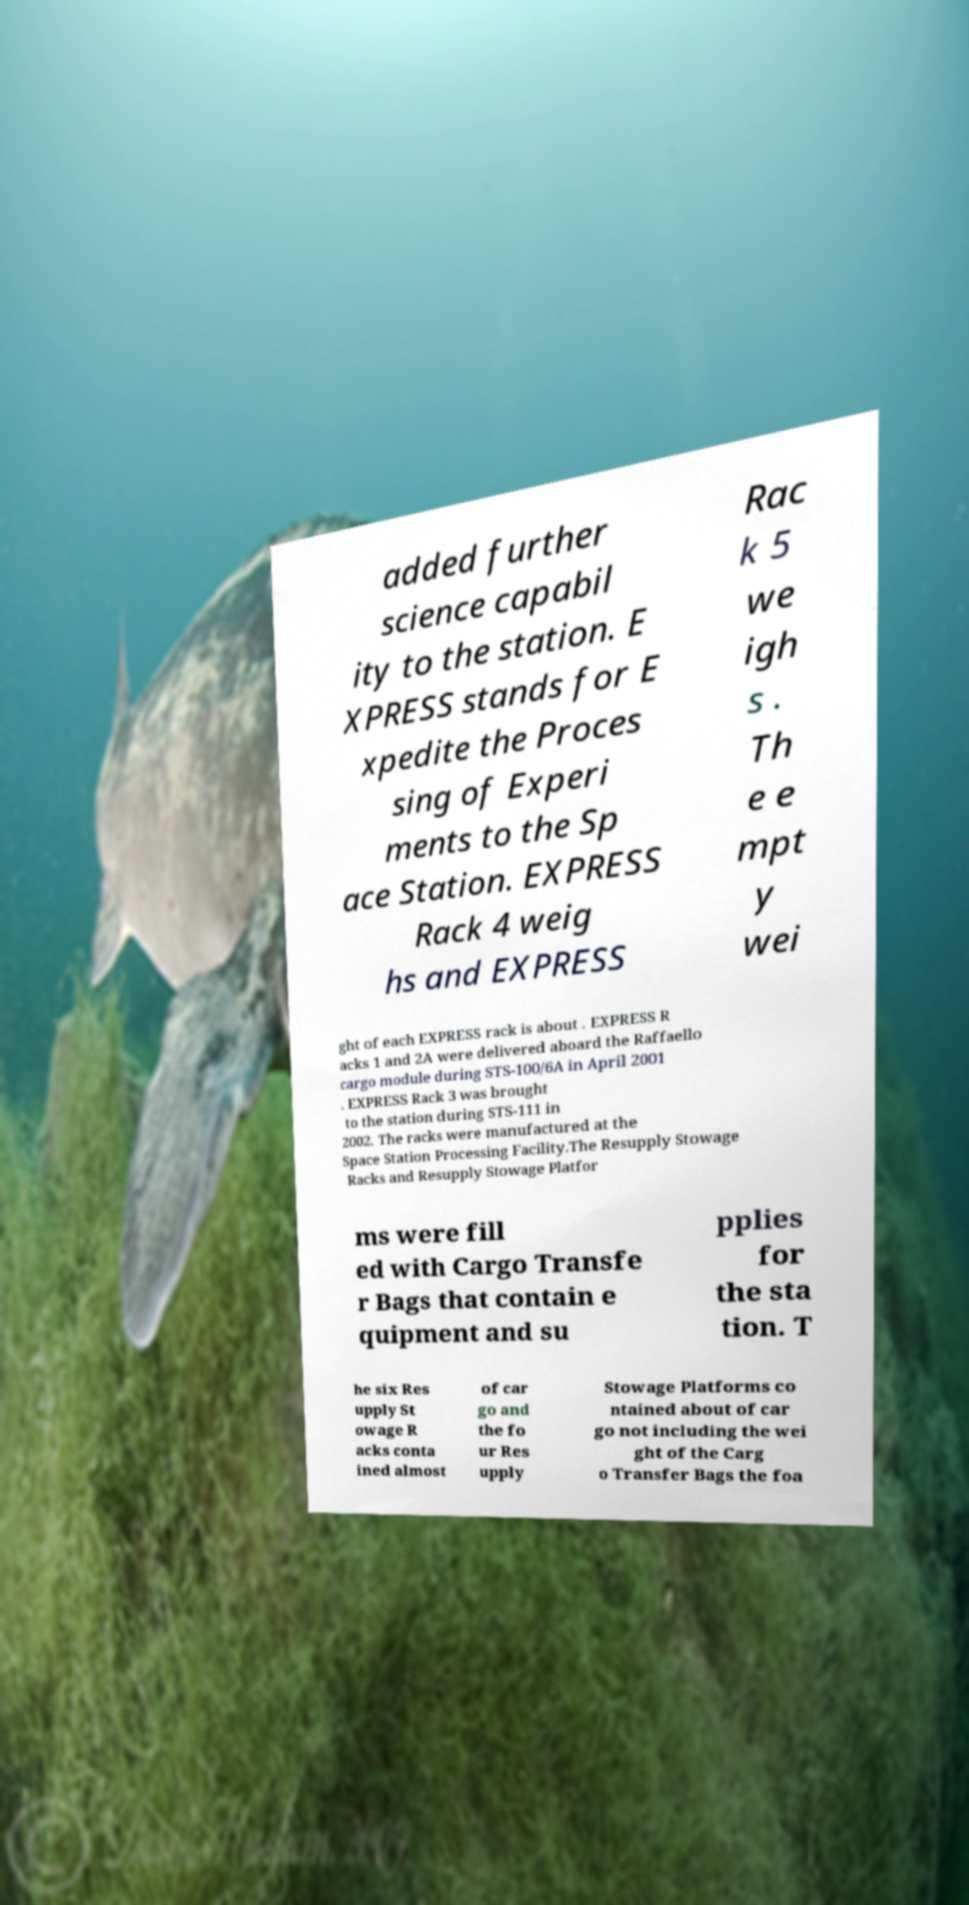Could you assist in decoding the text presented in this image and type it out clearly? added further science capabil ity to the station. E XPRESS stands for E xpedite the Proces sing of Experi ments to the Sp ace Station. EXPRESS Rack 4 weig hs and EXPRESS Rac k 5 we igh s . Th e e mpt y wei ght of each EXPRESS rack is about . EXPRESS R acks 1 and 2A were delivered aboard the Raffaello cargo module during STS-100/6A in April 2001 . EXPRESS Rack 3 was brought to the station during STS-111 in 2002. The racks were manufactured at the Space Station Processing Facility.The Resupply Stowage Racks and Resupply Stowage Platfor ms were fill ed with Cargo Transfe r Bags that contain e quipment and su pplies for the sta tion. T he six Res upply St owage R acks conta ined almost of car go and the fo ur Res upply Stowage Platforms co ntained about of car go not including the wei ght of the Carg o Transfer Bags the foa 